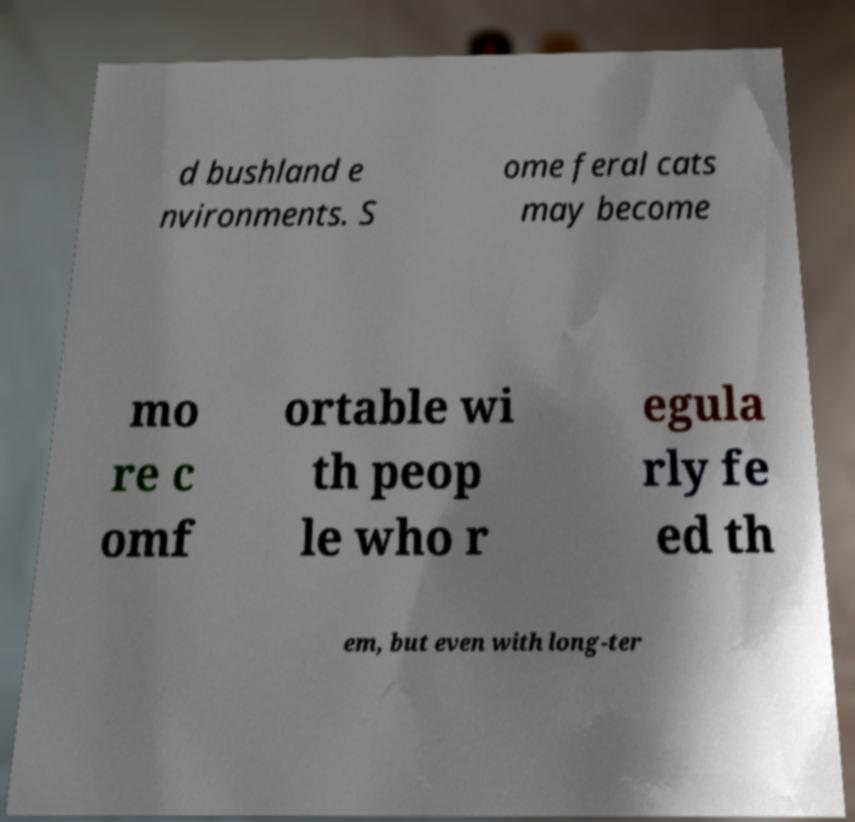Can you read and provide the text displayed in the image?This photo seems to have some interesting text. Can you extract and type it out for me? d bushland e nvironments. S ome feral cats may become mo re c omf ortable wi th peop le who r egula rly fe ed th em, but even with long-ter 